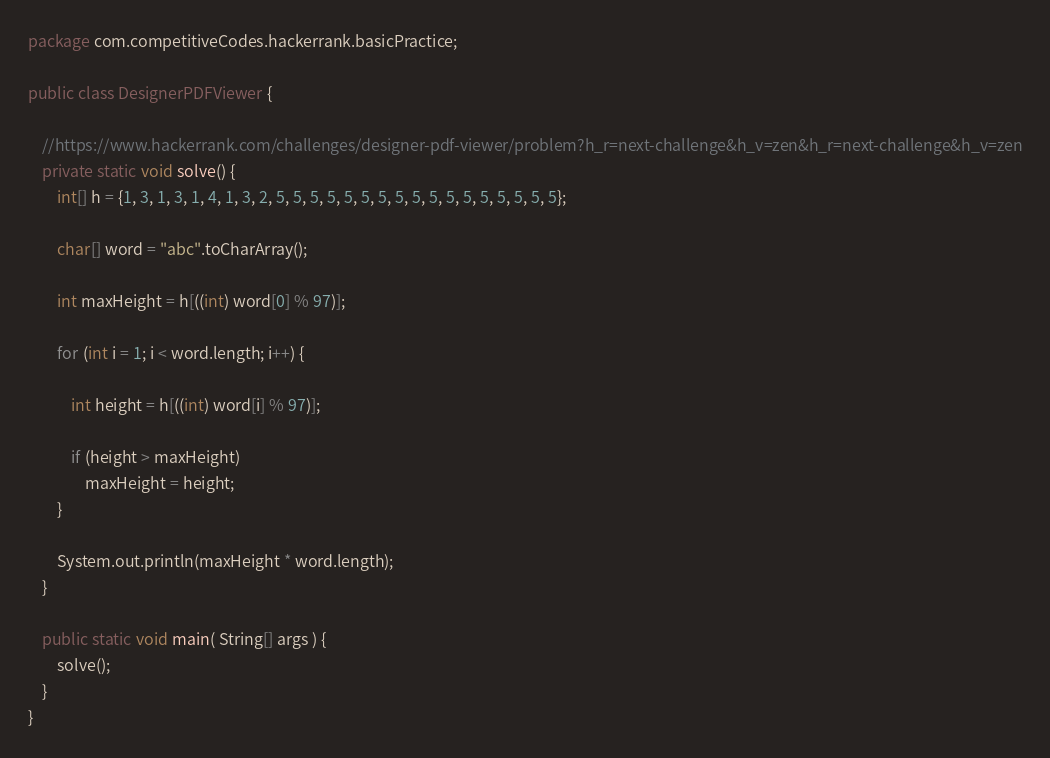<code> <loc_0><loc_0><loc_500><loc_500><_Java_>package com.competitiveCodes.hackerrank.basicPractice;

public class DesignerPDFViewer {

    //https://www.hackerrank.com/challenges/designer-pdf-viewer/problem?h_r=next-challenge&h_v=zen&h_r=next-challenge&h_v=zen
    private static void solve() {
        int[] h = {1, 3, 1, 3, 1, 4, 1, 3, 2, 5, 5, 5, 5, 5, 5, 5, 5, 5, 5, 5, 5, 5, 5, 5, 5, 5};

        char[] word = "abc".toCharArray();

        int maxHeight = h[((int) word[0] % 97)];

        for (int i = 1; i < word.length; i++) {

            int height = h[((int) word[i] % 97)];

            if (height > maxHeight)
                maxHeight = height;
        }

        System.out.println(maxHeight * word.length);
    }

    public static void main( String[] args ) {
        solve();
    }
}
</code> 